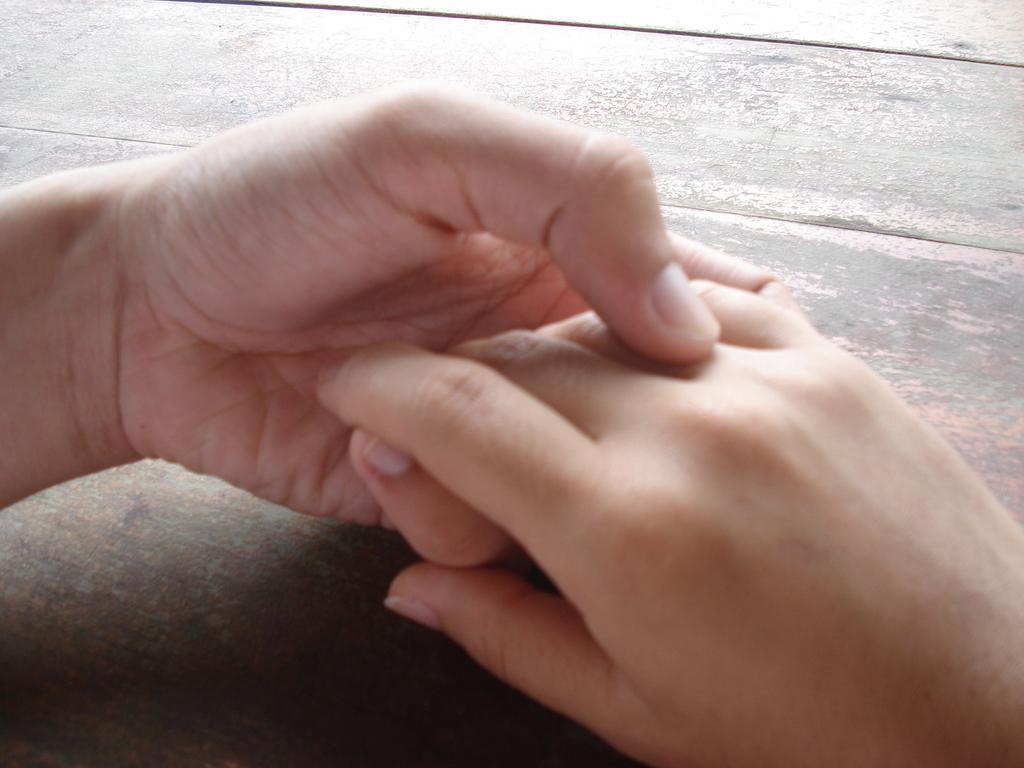How would you summarize this image in a sentence or two? In this picture we can see hands on a table. 